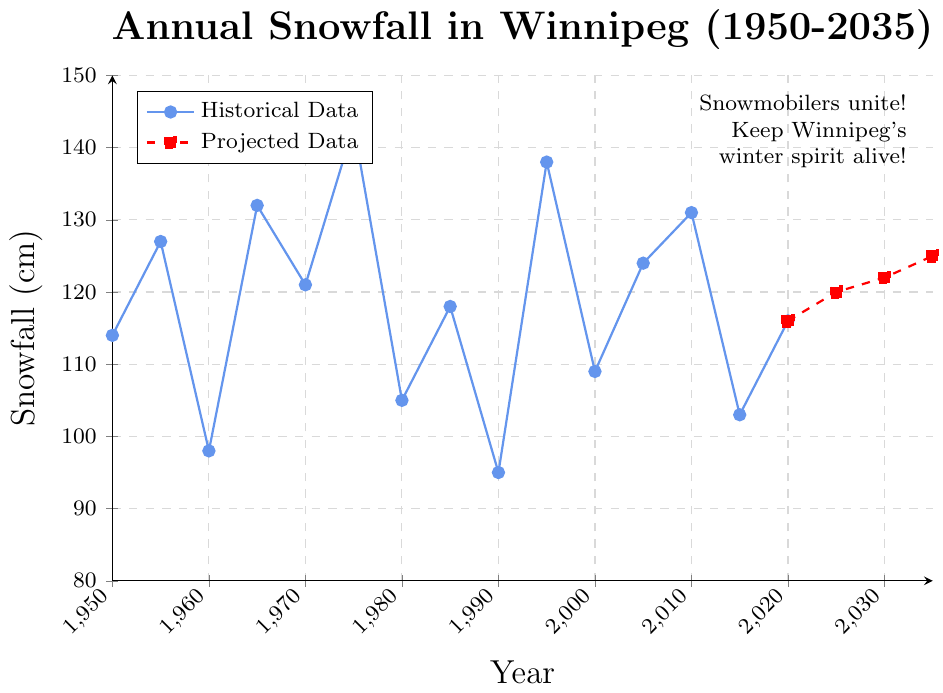What was the annual snowfall in 1970? The figure shows the data points representing annual snowfall for different years. Look for the year 1970 on the x-axis and check the corresponding y-axis value. The data point at 1970 corresponds to approximately 121 cm of snowfall.
Answer: 121 cm Which year had the higher snowfall: 1985 or 2020? Identify the data points for 1985 and 2020, then compare the y-axis values. 1985 had a snowfall of 118 cm, whereas 2020 had a snowfall of 116 cm. Since 118 cm is higher than 116 cm, 1985 had more snowfall.
Answer: 1985 What is the visual difference between historical and projected data? The historical data is represented by solid blue line with circle markers, while the projected data is represented by a dashed red line with square markers. This visual distinction helps differentiate between actual recorded snowfall and future projections.
Answer: Solid blue line with circles for historical, dashed red line with squares for projected What is the average snowfall between 1975 and 1990? Identify the data points in the figure for the years 1975, 1980, 1985, and 1990: 143 cm, 105 cm, 118 cm, and 95 cm. Sum these values and divide by the number of years (4). (143 + 105 + 118 + 95) / 4 = 115.25 cm
Answer: 115.25 cm Is the snowfall trend projected to increase or decrease after 2020? Observe the projected data from 2020 to 2035 on the figure. The values increase from 116 cm in 2020 to 125 cm in 2035, indicating an upward trend.
Answer: Increase How much is the difference in snowfall between the years with the maximum and minimum recorded snowfall? Locate the maximum and minimum snowfall values among the data points. The maximum is 143 cm (1975) and the minimum is 95 cm (1990). Calculate the difference: 143 cm - 95 cm = 48 cm.
Answer: 48 cm What is the trend in snowfall from 1950 to 2020? Observe the historical data points from 1950 to 2020. The data shows fluctuations, but overall there isn't a consistent upward or downward trend, indicating variability in annual snowfall.
Answer: Variable without clear trend Between 2015 and 2020, did the snowfall increase or decrease? Look at the figure's data points for 2015 and 2020. In 2015, snowfall is 103 cm, and in 2020, it is 116 cm. The snowfall increased from 103 cm to 116 cm.
Answer: Increase 